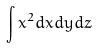Convert formula to latex. <formula><loc_0><loc_0><loc_500><loc_500>\int x ^ { 2 } d x d y d z</formula> 